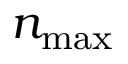Convert formula to latex. <formula><loc_0><loc_0><loc_500><loc_500>n _ { \max }</formula> 